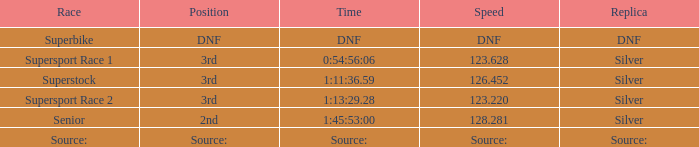Which location has a velocity of 123.220? 3rd. 